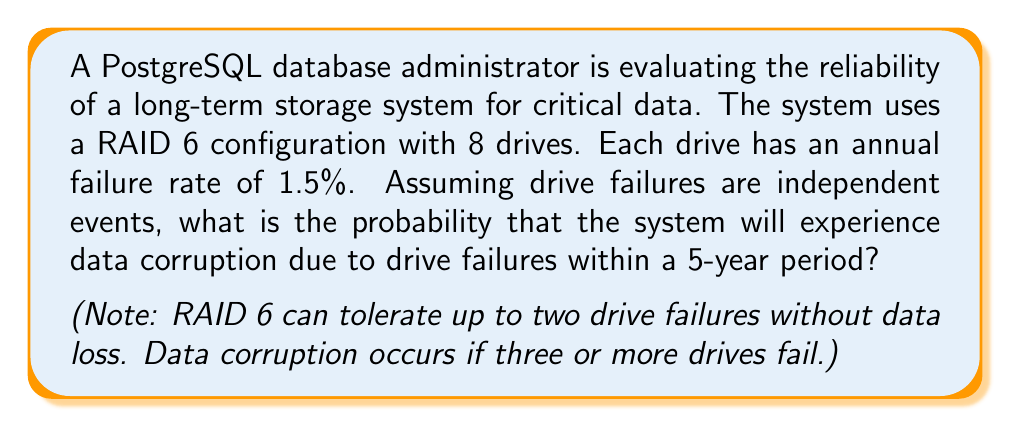Give your solution to this math problem. To solve this problem, we'll follow these steps:

1) First, let's calculate the probability of a single drive failing within 5 years:
   
   $P(\text{drive fails in 5 years}) = 1 - (1 - 0.015)^5 \approx 0.0723$

2) Now, we need to calculate the probability of 3 or more drives failing out of 8 drives in 5 years. This is equivalent to 1 minus the probability of 0, 1, or 2 drives failing.

3) We can use the binomial probability formula:

   $P(X = k) = \binom{n}{k} p^k (1-p)^{n-k}$

   Where:
   $n = 8$ (total number of drives)
   $p = 0.0723$ (probability of a single drive failing in 5 years)
   $k = 0, 1, 2$ (number of failed drives)

4) Calculate the probabilities:

   $P(X = 0) = \binom{8}{0} 0.0723^0 (1-0.0723)^8 \approx 0.5465$
   
   $P(X = 1) = \binom{8}{1} 0.0723^1 (1-0.0723)^7 \approx 0.3414$
   
   $P(X = 2) = \binom{8}{2} 0.0723^2 (1-0.0723)^6 \approx 0.0928$

5) Sum these probabilities:

   $P(X \leq 2) = 0.5465 + 0.3414 + 0.0928 \approx 0.9807$

6) The probability of data corruption (3 or more drives failing) is the complement of this:

   $P(X \geq 3) = 1 - P(X \leq 2) = 1 - 0.9807 \approx 0.0193$

Therefore, the probability of data corruption due to drive failures within a 5-year period is approximately 0.0193 or 1.93%.
Answer: $0.0193$ or $1.93\%$ 